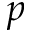Convert formula to latex. <formula><loc_0><loc_0><loc_500><loc_500>p</formula> 